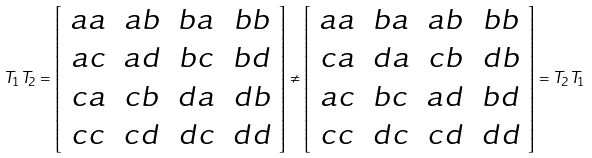Convert formula to latex. <formula><loc_0><loc_0><loc_500><loc_500>T _ { 1 } T _ { 2 } = \left [ \begin{array} { c c c c } a a & a b & b a & b b \\ a c & a d & b c & b d \\ c a & c b & d a & d b \\ c c & c d & d c & d d \end{array} \right ] \neq \left [ \begin{array} { c c c c } a a & b a & a b & b b \\ c a & d a & c b & d b \\ a c & b c & a d & b d \\ c c & d c & c d & d d \end{array} \right ] = T _ { 2 } T _ { 1 }</formula> 